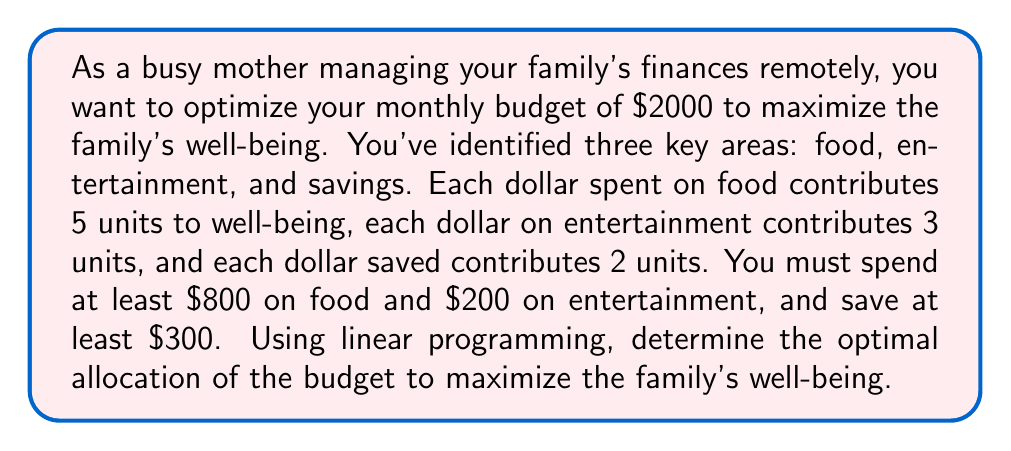Teach me how to tackle this problem. Let's approach this problem using linear programming:

1. Define variables:
   $x$ = amount spent on food
   $y$ = amount spent on entertainment
   $z$ = amount saved

2. Objective function:
   Maximize well-being: $5x + 3y + 2z$

3. Constraints:
   a) Total budget: $x + y + z = 2000$
   b) Minimum food: $x \geq 800$
   c) Minimum entertainment: $y \geq 200$
   d) Minimum savings: $z \geq 300$
   e) Non-negativity: $x, y, z \geq 0$

4. Set up the linear programming problem:
   
   Maximize: $5x + 3y + 2z$
   Subject to:
   $$\begin{aligned}
   x + y + z &= 2000 \\
   x &\geq 800 \\
   y &\geq 200 \\
   z &\geq 300 \\
   x, y, z &\geq 0
   \end{aligned}$$

5. Solve using the simplex method or linear programming software:
   
   The optimal solution is:
   $x = 1500$ (food)
   $y = 200$ (entertainment)
   $z = 300$ (savings)

6. Check the solution:
   - Total budget: $1500 + 200 + 300 = 2000$ (satisfied)
   - Minimum constraints are met for all categories
   - Maximum well-being: $5(1500) + 3(200) + 2(300) = 8100$ units

This allocation maximizes the family's well-being while meeting all constraints.
Answer: The optimal allocation of the family budget is:
Food: $1500
Entertainment: $200
Savings: $300
This allocation results in a maximum well-being of 8100 units. 